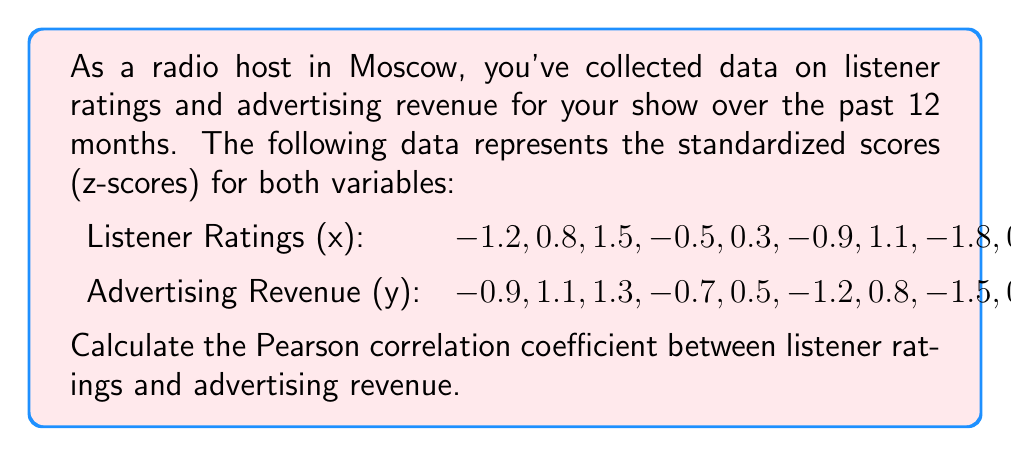Provide a solution to this math problem. To calculate the Pearson correlation coefficient (r) between listener ratings (x) and advertising revenue (y), we'll use the formula:

$$ r = \frac{\sum_{i=1}^{n} (x_i - \bar{x})(y_i - \bar{y})}{\sqrt{\sum_{i=1}^{n} (x_i - \bar{x})^2 \sum_{i=1}^{n} (y_i - \bar{y})^2}} $$

Since we're given standardized scores (z-scores), we can simplify this formula. For z-scores, the mean is always 0 and the standard deviation is always 1. This simplifies our calculation to:

$$ r = \frac{\sum_{i=1}^{n} x_i y_i}{n} $$

Where n is the number of data points (12 in this case).

Let's calculate the sum of the products of x and y:

$(-1.2 \times -0.9) + (0.8 \times 1.1) + (1.5 \times 1.3) + (-0.5 \times -0.7) + (0.3 \times 0.5) + (-0.9 \times -1.2) + (1.1 \times 0.8) + (-1.8 \times -1.5) + (0.6 \times 0.2) + (1.9 \times 1.7) + (-0.2 \times -0.4) + (0.4 \times 0.1)$

$= 1.08 + 0.88 + 1.95 + 0.35 + 0.15 + 1.08 + 0.88 + 2.70 + 0.12 + 3.23 + 0.08 + 0.04$

$= 12.54$

Now, we divide by the number of data points:

$r = \frac{12.54}{12} = 1.045$
Answer: The Pearson correlation coefficient between listener ratings and advertising revenue is $r = 1.045$. 